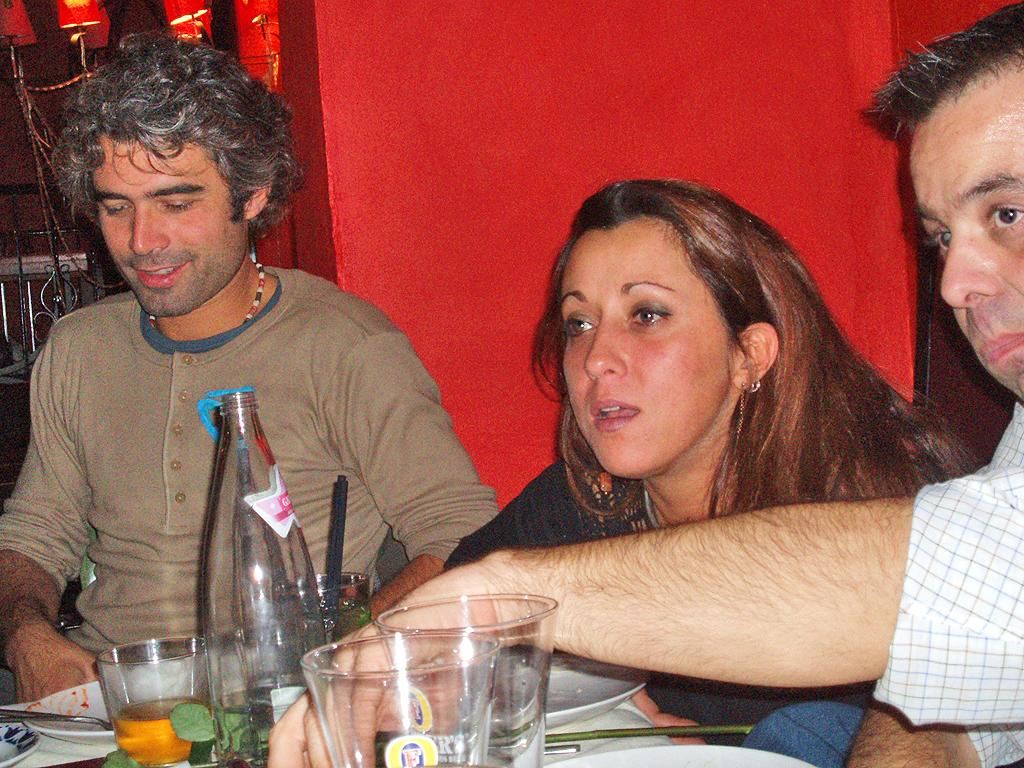What are the persons in the image doing? The persons in the image are sitting on chairs. What is in front of the persons? There is a table in front of the persons. What objects can be seen on the table? There is a bottle, plates, spoons, and glasses on the table. What is the color of the wall in the image? The wall is in red color. Where is the vase placed in the image? There is no vase present in the image. What type of vacation is the group planning in the image? There is no indication of a vacation or any planning in the image. 